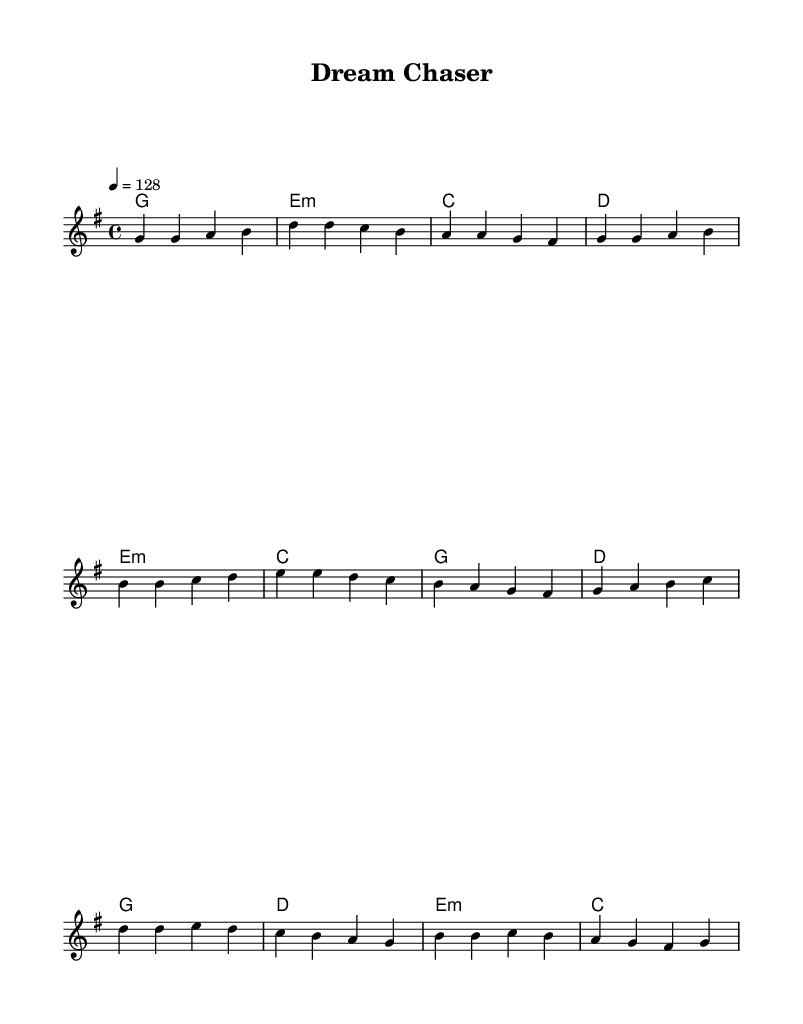What is the key signature of this music? The key signature is G major, which has one sharp (F#).
Answer: G major What is the time signature of this music? The time signature is 4/4, indicating four beats per measure.
Answer: 4/4 What is the tempo marking for this piece? The tempo marking is 128 beats per minute, suggesting an upbeat feel to the music.
Answer: 128 How many bars are there in the verse section? The verse section consists of 4 bars, as indicated by the grouped notes and measures in that segment.
Answer: 4 What is the first chord in the verse? The first chord in the verse is G major, represented by the chord notation at the beginning of the verse.
Answer: G Which section features a modulation to E minor? The pre-chorus section features a modulation to E minor, as indicated by the chord change listed there.
Answer: Pre-Chorus What is the main theme expressed in the lyrics implied by the melody? The melody's structure and repetitive phrases suggest a theme centered around pursuing dreams and overcoming challenges typical of K-Pop.
Answer: Pursuing dreams 